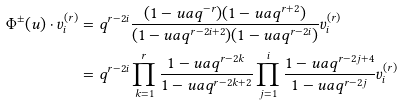Convert formula to latex. <formula><loc_0><loc_0><loc_500><loc_500>\Phi ^ { \pm } ( u ) \cdot v ^ { ( r ) } _ { i } & = q ^ { r - 2 i } \frac { ( 1 - u a q ^ { - r } ) ( 1 - u a q ^ { r + 2 } ) } { ( 1 - u a q ^ { r - 2 i + 2 } ) ( 1 - u a q ^ { r - 2 i } ) } v ^ { ( r ) } _ { i } \\ & = q ^ { r - 2 i } \prod _ { k = 1 } ^ { r } \frac { 1 - u a q ^ { r - 2 k } } { 1 - u a q ^ { r - 2 k + 2 } } \prod _ { j = 1 } ^ { i } \frac { 1 - u a q ^ { r - 2 j + 4 } } { 1 - u a q ^ { r - 2 j } } v ^ { ( r ) } _ { i }</formula> 